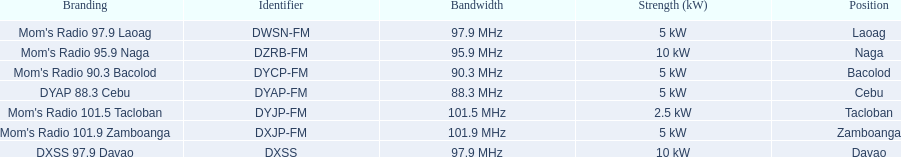What is the power capacity in kw for each team? 5 kW, 10 kW, 5 kW, 5 kW, 2.5 kW, 5 kW, 10 kW. Which is the lowest? 2.5 kW. What station has this amount of power? Mom's Radio 101.5 Tacloban. 